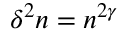<formula> <loc_0><loc_0><loc_500><loc_500>\delta ^ { 2 } n = n ^ { 2 \gamma }</formula> 